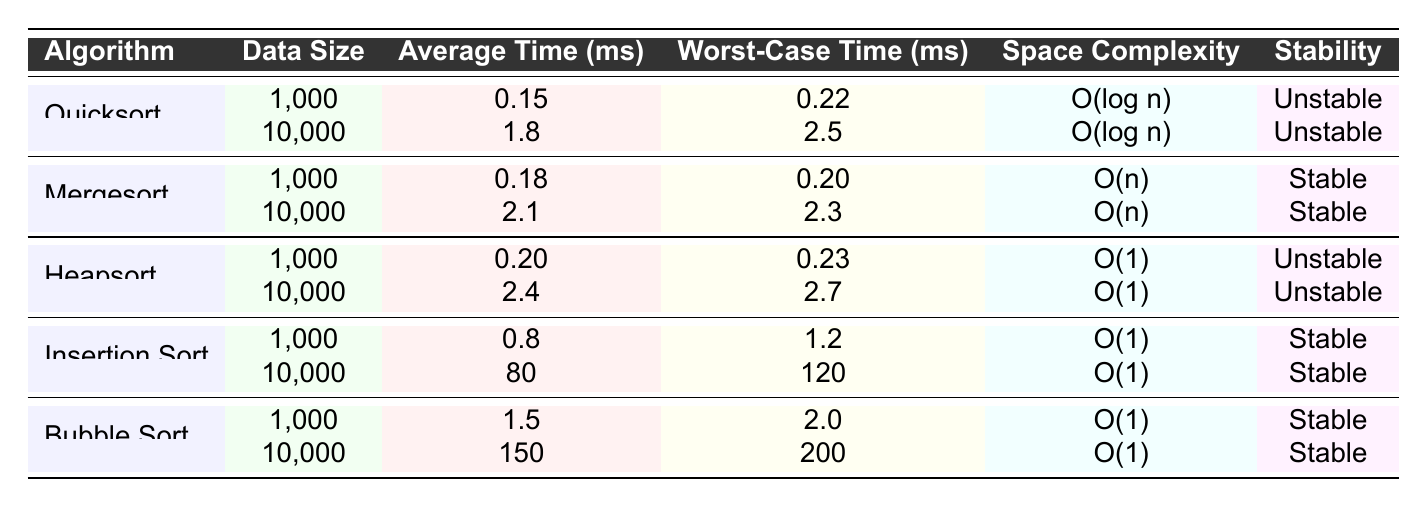What is the average time for Quicksort with a data size of 10,000? The table shows that for Quicksort with a data size of 10,000, the average time is listed as 1.8 ms.
Answer: 1.8 ms Which sorting algorithm is stable? The table indicates that Mergesort, Insertion Sort, and Bubble Sort are marked as stable, while Quicksort and Heapsort are unstable.
Answer: Mergesort, Insertion Sort, Bubble Sort What is the worst-case time for Insertion Sort with a data size of 1,000? Referring to the table, the worst-case time for Insertion Sort with a data size of 1,000 is 1.2 ms.
Answer: 1.2 ms What is the average time difference between Heapsort and Mergesort for a data size of 10,000? The average time for Heapsort at 10,000 is 2.4 ms, and for Mergesort, it is 2.1 ms. The difference is 2.4 ms - 2.1 ms = 0.3 ms.
Answer: 0.3 ms Is it true that Bubble Sort has a better worst-case time than Insertion Sort for data size 1,000? The worst-case time for Bubble Sort (2.0 ms) is greater than that of Insertion Sort (1.2 ms) for a data size of 1,000. Thus, the statement is false.
Answer: False Which algorithm has the best average time for a data size of 10,000? Comparing the average times at 10,000: Quicksort (1.8 ms), Mergesort (2.1 ms), Heapsort (2.4 ms), Insertion Sort (80 ms), Bubble Sort (150 ms), Quicksort has the best average time at 1.8 ms.
Answer: Quicksort What is the space complexity of Mergesort? According to the table, the space complexity of Mergesort is O(n), as indicated in its corresponding row.
Answer: O(n) Which algorithm has the highest average time amongst the sorting algorithms for a data size of 10,000? By examining the average times at 10,000: Insertion Sort (80 ms) has the highest average time compared to all other algorithms listed.
Answer: Insertion Sort Do any of the sorting algorithms have a space complexity of O(1)? The table shows that Heapsort and Insertion Sort both have a space complexity of O(1), making the statement true.
Answer: True What is the overall average time of the Bubble Sort algorithm across both data sizes? To find this, we add the average times for all Bubble Sort entries: (1.5 ms + 150 ms) / 2 = 75.25 ms, thus the overall average time is 75.25 ms.
Answer: 75.25 ms 